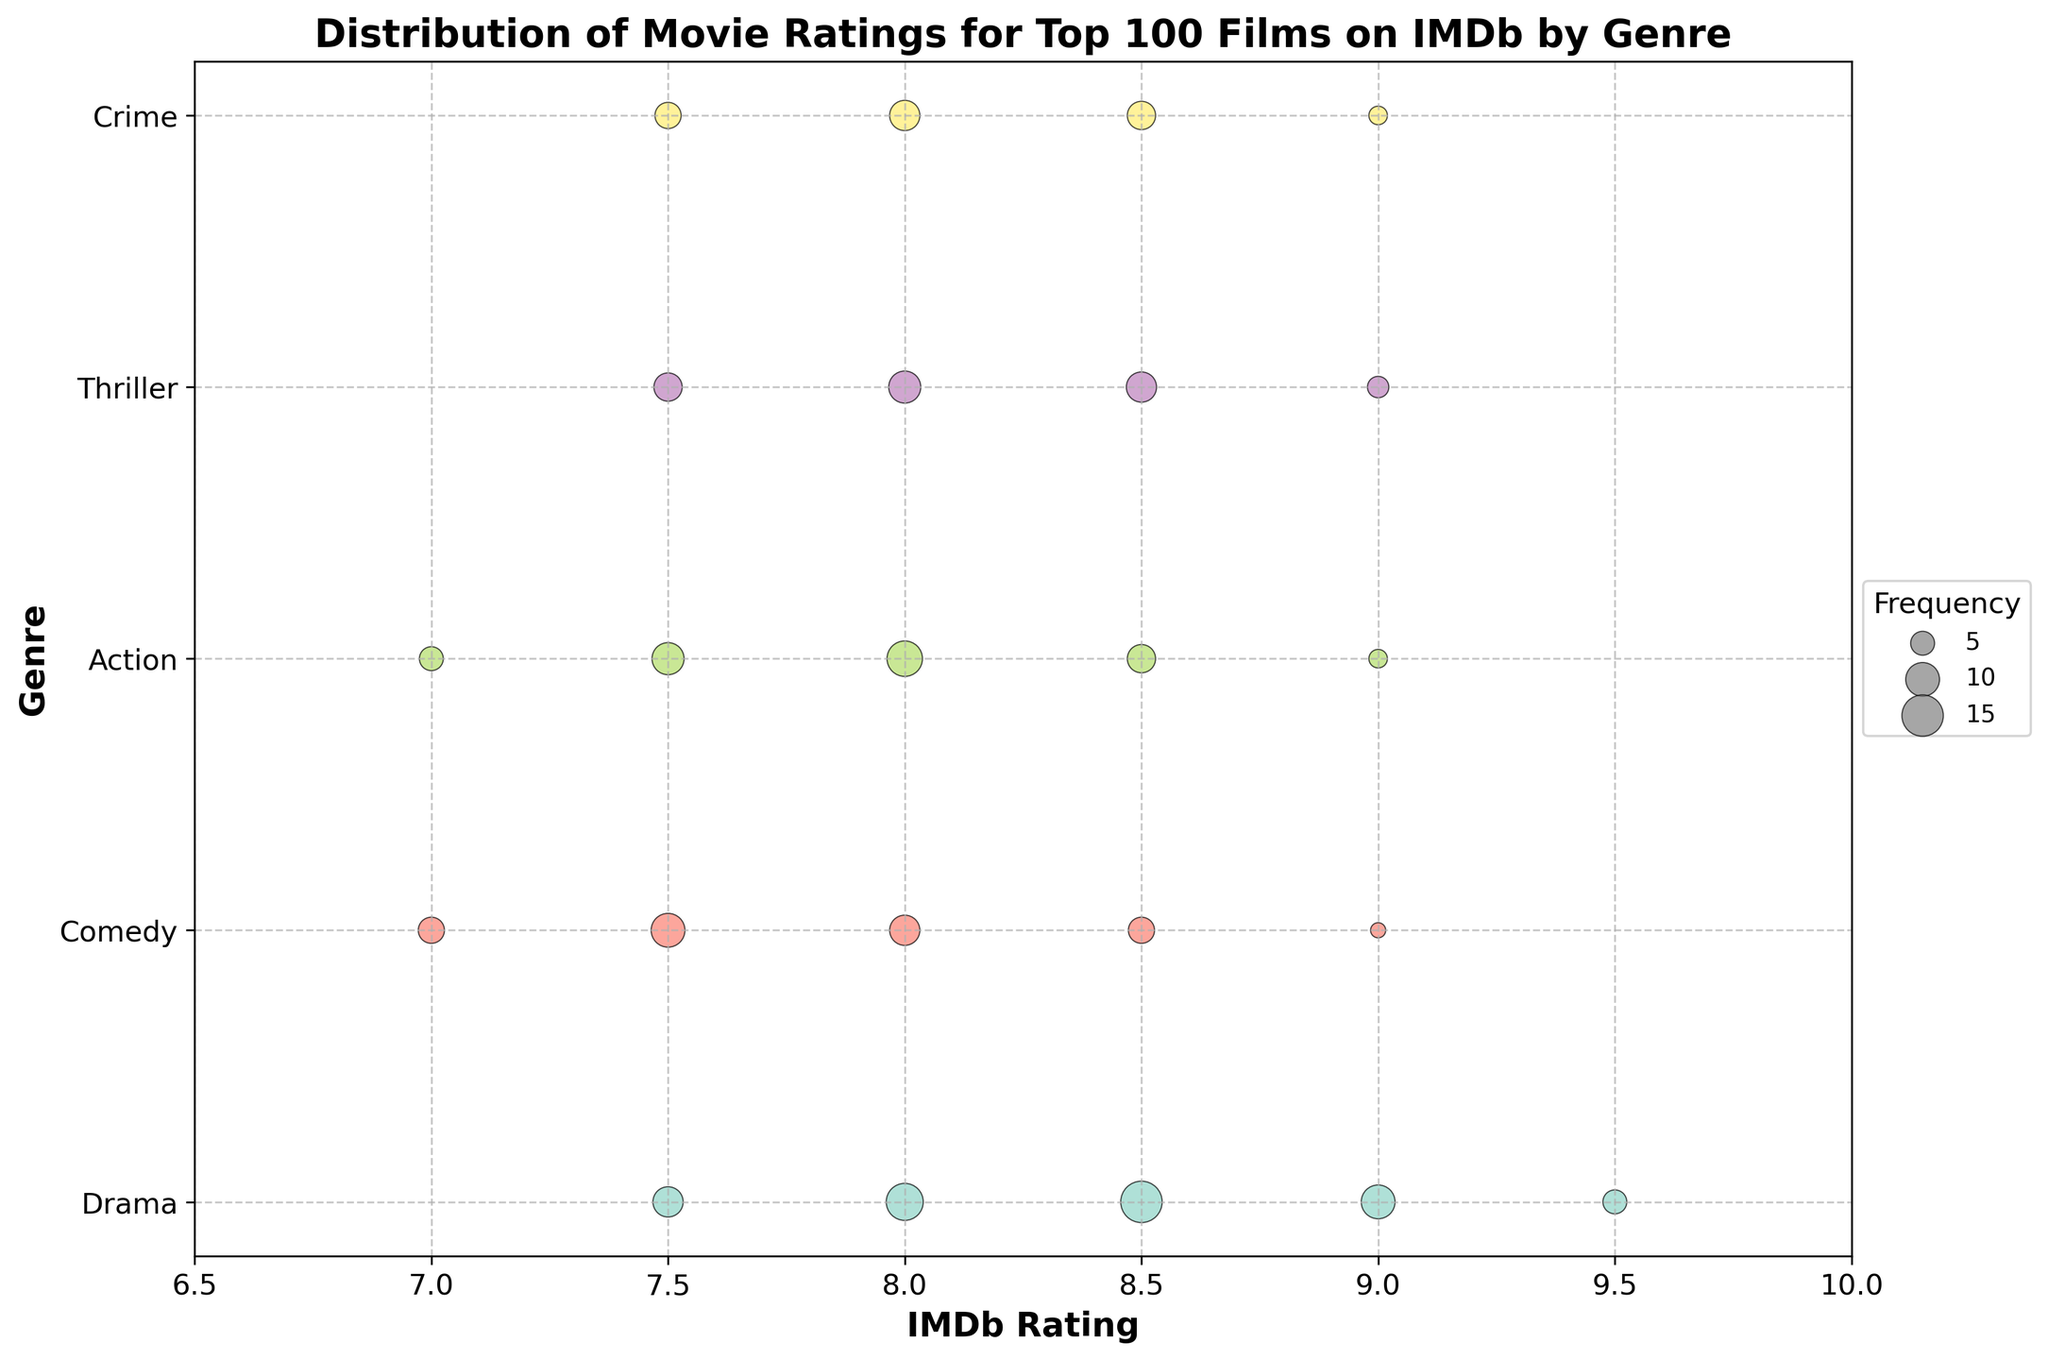What is the title of the figure? The title is usually located at the top of the figure. Here we see "Distribution of Movie Ratings for Top 100 Films on IMDb by Genre".
Answer: Distribution of Movie Ratings for Top 100 Films on IMDb by Genre Which genre appears to have the highest rating of 9.5? To determine this, visually scan the scatter points and observe which genre has a rating of 9.5.
Answer: Drama What is the most frequent rating for Drama? By looking at the size of the scatter points for the Drama genre, the largest size corresponds to 8.5.
Answer: 8.5 How many genres have a rating of 9.0 in some frequency? By checking each genre's scatter points to see which have a 9.0 rating, we notice Drama, Comedy, Action, Thriller, and Crime.
Answer: 5 Which genre displays the widest range of ratings? By visually comparing the span of ratings across the scatter points for each genre, Drama spans from 7.5 to 9.5, which seems the widest.
Answer: Drama How many scatter points are there in total for Comedy? By counting the scatter points for the Comedy genre, we see there are 5 points.
Answer: 5 Which genre tends to have slightly higher ratings, Action or Thriller? Compare the scatter points' general positions for both genres and observe that Thriller tends to have slightly higher ratings (mainly 8.0 to 9.0).
Answer: Thriller Which rating has the highest frequency across all genres? By identifying the scatter point sizes across all genres, the rating of 8.5 in Drama appears to be the largest.
Answer: 8.5 (Drama) What is the total number of data points represented across all genres? Sum all the scatter points across each genre: Drama (5), Comedy (5), Action (5), Thriller (4), Crime (4).
Answer: 23 Which genre has the smallest frequency for the rating of 8.0? Observe the scatter point sizes for the 8.0 rating in all genres. Comedy has the smallest.
Answer: Comedy 